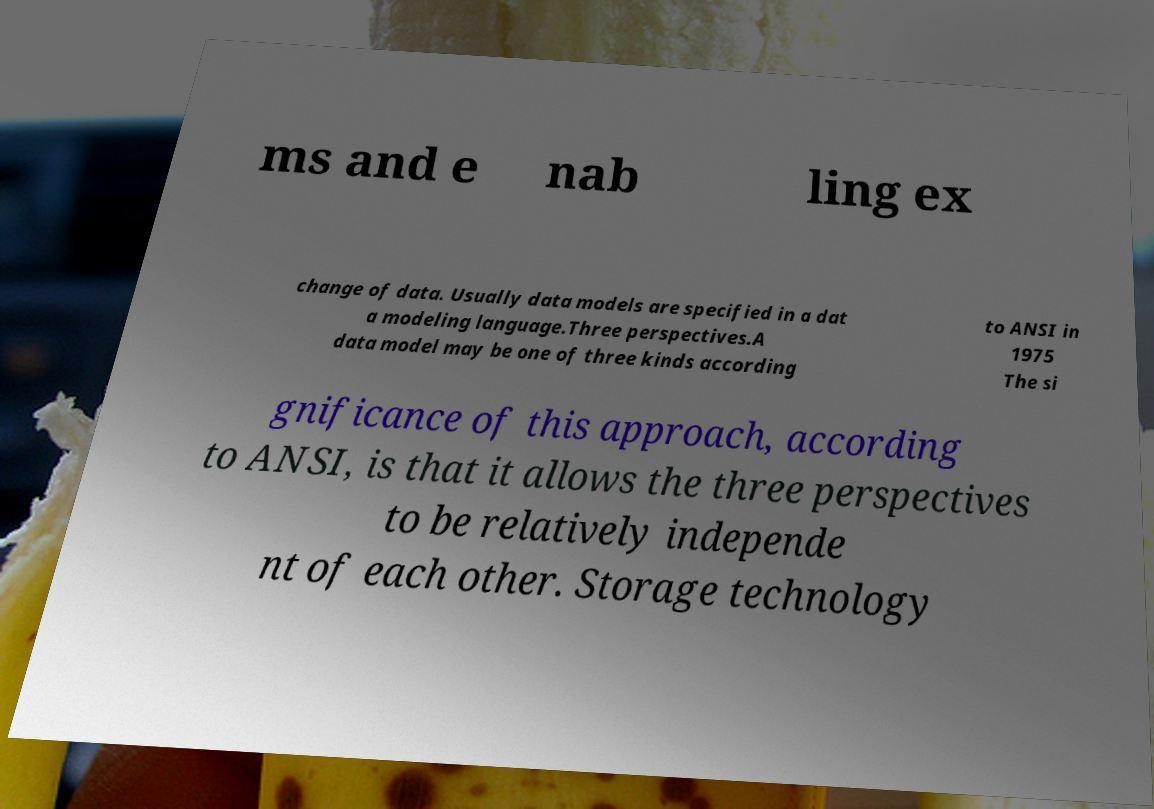There's text embedded in this image that I need extracted. Can you transcribe it verbatim? ms and e nab ling ex change of data. Usually data models are specified in a dat a modeling language.Three perspectives.A data model may be one of three kinds according to ANSI in 1975 The si gnificance of this approach, according to ANSI, is that it allows the three perspectives to be relatively independe nt of each other. Storage technology 